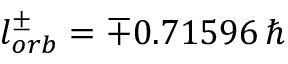Convert formula to latex. <formula><loc_0><loc_0><loc_500><loc_500>l _ { o r b } ^ { \pm } = \mp 0 . 7 1 5 9 6 \, \hbar</formula> 